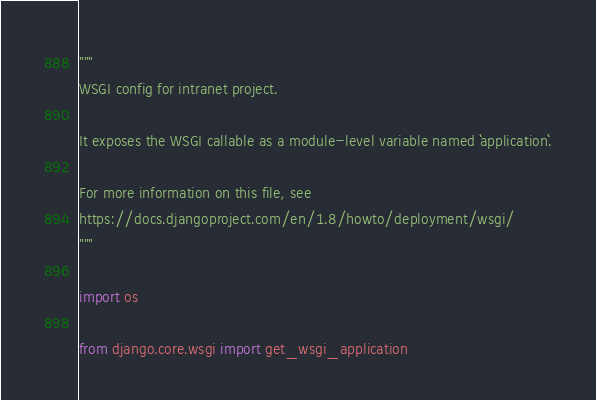<code> <loc_0><loc_0><loc_500><loc_500><_Python_>"""
WSGI config for intranet project.

It exposes the WSGI callable as a module-level variable named ``application``.

For more information on this file, see
https://docs.djangoproject.com/en/1.8/howto/deployment/wsgi/
"""

import os

from django.core.wsgi import get_wsgi_application
</code> 